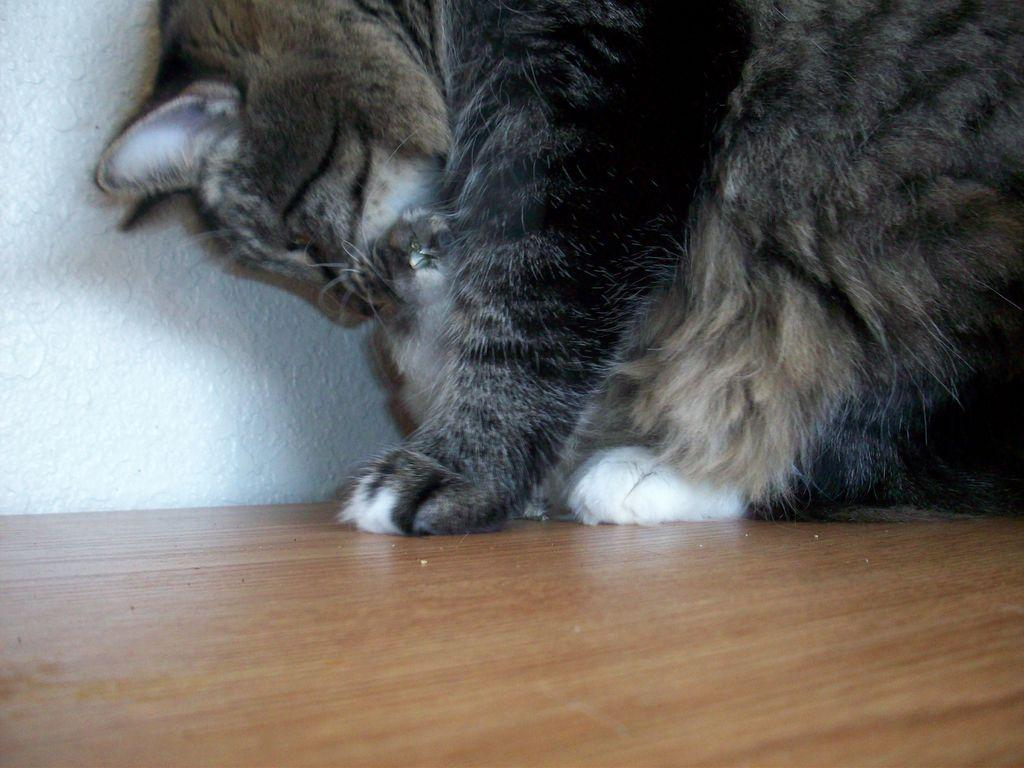What type of animal is in the image? There is a cat in the image. What is the surface beneath the cat? The cat is on a wooden floor. What can be seen in the background of the image? There is a wall in the background of the image. What type of tramp is the cat using in the image? There is no tramp present in the image; the cat is simply on a wooden floor. 